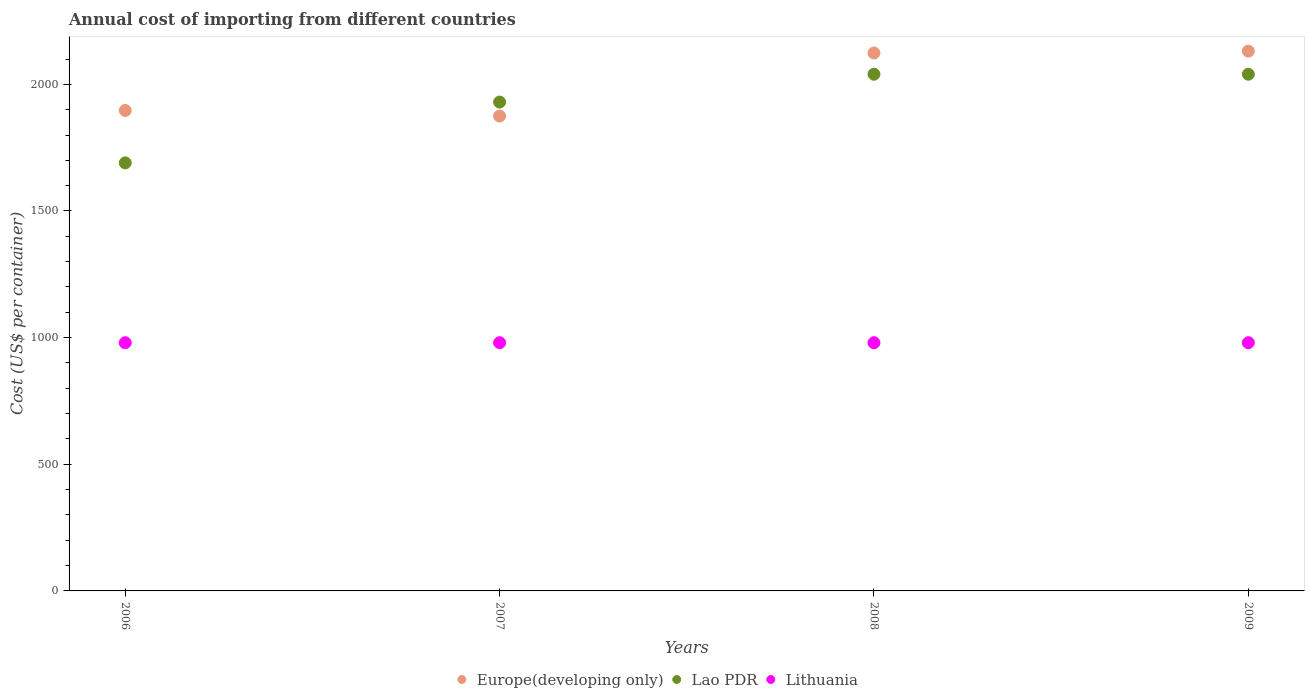How many different coloured dotlines are there?
Keep it short and to the point. 3. What is the total annual cost of importing in Lao PDR in 2006?
Your response must be concise. 1690. Across all years, what is the maximum total annual cost of importing in Lao PDR?
Your response must be concise. 2040. Across all years, what is the minimum total annual cost of importing in Europe(developing only)?
Offer a very short reply. 1874.94. In which year was the total annual cost of importing in Lao PDR maximum?
Ensure brevity in your answer.  2008. In which year was the total annual cost of importing in Lao PDR minimum?
Your answer should be compact. 2006. What is the total total annual cost of importing in Europe(developing only) in the graph?
Keep it short and to the point. 8026.94. What is the difference between the total annual cost of importing in Europe(developing only) in 2007 and that in 2008?
Ensure brevity in your answer.  -249. What is the difference between the total annual cost of importing in Europe(developing only) in 2007 and the total annual cost of importing in Lao PDR in 2009?
Make the answer very short. -165.06. What is the average total annual cost of importing in Lithuania per year?
Make the answer very short. 980. In the year 2008, what is the difference between the total annual cost of importing in Lao PDR and total annual cost of importing in Lithuania?
Ensure brevity in your answer.  1060. In how many years, is the total annual cost of importing in Lithuania greater than 600 US$?
Provide a short and direct response. 4. What is the ratio of the total annual cost of importing in Lao PDR in 2006 to that in 2009?
Provide a succinct answer. 0.83. Is the total annual cost of importing in Europe(developing only) in 2007 less than that in 2009?
Keep it short and to the point. Yes. What is the difference between the highest and the second highest total annual cost of importing in Europe(developing only)?
Provide a short and direct response. 7.16. What is the difference between the highest and the lowest total annual cost of importing in Lao PDR?
Offer a terse response. 350. In how many years, is the total annual cost of importing in Lithuania greater than the average total annual cost of importing in Lithuania taken over all years?
Make the answer very short. 0. Is the sum of the total annual cost of importing in Lao PDR in 2008 and 2009 greater than the maximum total annual cost of importing in Lithuania across all years?
Provide a short and direct response. Yes. Is it the case that in every year, the sum of the total annual cost of importing in Lithuania and total annual cost of importing in Lao PDR  is greater than the total annual cost of importing in Europe(developing only)?
Keep it short and to the point. Yes. Does the total annual cost of importing in Lao PDR monotonically increase over the years?
Make the answer very short. No. Is the total annual cost of importing in Lithuania strictly greater than the total annual cost of importing in Europe(developing only) over the years?
Your response must be concise. No. Is the total annual cost of importing in Lithuania strictly less than the total annual cost of importing in Lao PDR over the years?
Make the answer very short. Yes. How many years are there in the graph?
Offer a terse response. 4. Are the values on the major ticks of Y-axis written in scientific E-notation?
Offer a very short reply. No. Does the graph contain grids?
Your response must be concise. No. Where does the legend appear in the graph?
Provide a short and direct response. Bottom center. How are the legend labels stacked?
Keep it short and to the point. Horizontal. What is the title of the graph?
Provide a short and direct response. Annual cost of importing from different countries. What is the label or title of the Y-axis?
Ensure brevity in your answer.  Cost (US$ per container). What is the Cost (US$ per container) in Europe(developing only) in 2006?
Keep it short and to the point. 1896.94. What is the Cost (US$ per container) of Lao PDR in 2006?
Your answer should be compact. 1690. What is the Cost (US$ per container) in Lithuania in 2006?
Give a very brief answer. 980. What is the Cost (US$ per container) in Europe(developing only) in 2007?
Your answer should be very brief. 1874.94. What is the Cost (US$ per container) of Lao PDR in 2007?
Offer a terse response. 1930. What is the Cost (US$ per container) in Lithuania in 2007?
Make the answer very short. 980. What is the Cost (US$ per container) of Europe(developing only) in 2008?
Your answer should be very brief. 2123.94. What is the Cost (US$ per container) in Lao PDR in 2008?
Ensure brevity in your answer.  2040. What is the Cost (US$ per container) of Lithuania in 2008?
Your answer should be very brief. 980. What is the Cost (US$ per container) in Europe(developing only) in 2009?
Offer a terse response. 2131.11. What is the Cost (US$ per container) of Lao PDR in 2009?
Ensure brevity in your answer.  2040. What is the Cost (US$ per container) of Lithuania in 2009?
Your response must be concise. 980. Across all years, what is the maximum Cost (US$ per container) in Europe(developing only)?
Make the answer very short. 2131.11. Across all years, what is the maximum Cost (US$ per container) in Lao PDR?
Give a very brief answer. 2040. Across all years, what is the maximum Cost (US$ per container) of Lithuania?
Your answer should be compact. 980. Across all years, what is the minimum Cost (US$ per container) of Europe(developing only)?
Your answer should be compact. 1874.94. Across all years, what is the minimum Cost (US$ per container) in Lao PDR?
Provide a succinct answer. 1690. Across all years, what is the minimum Cost (US$ per container) of Lithuania?
Your answer should be compact. 980. What is the total Cost (US$ per container) of Europe(developing only) in the graph?
Offer a terse response. 8026.94. What is the total Cost (US$ per container) in Lao PDR in the graph?
Offer a terse response. 7700. What is the total Cost (US$ per container) of Lithuania in the graph?
Keep it short and to the point. 3920. What is the difference between the Cost (US$ per container) in Lao PDR in 2006 and that in 2007?
Keep it short and to the point. -240. What is the difference between the Cost (US$ per container) in Lithuania in 2006 and that in 2007?
Offer a terse response. 0. What is the difference between the Cost (US$ per container) of Europe(developing only) in 2006 and that in 2008?
Provide a succinct answer. -227. What is the difference between the Cost (US$ per container) of Lao PDR in 2006 and that in 2008?
Ensure brevity in your answer.  -350. What is the difference between the Cost (US$ per container) in Europe(developing only) in 2006 and that in 2009?
Offer a very short reply. -234.16. What is the difference between the Cost (US$ per container) of Lao PDR in 2006 and that in 2009?
Offer a very short reply. -350. What is the difference between the Cost (US$ per container) of Lithuania in 2006 and that in 2009?
Your answer should be very brief. 0. What is the difference between the Cost (US$ per container) of Europe(developing only) in 2007 and that in 2008?
Ensure brevity in your answer.  -249. What is the difference between the Cost (US$ per container) of Lao PDR in 2007 and that in 2008?
Your answer should be very brief. -110. What is the difference between the Cost (US$ per container) in Lithuania in 2007 and that in 2008?
Give a very brief answer. 0. What is the difference between the Cost (US$ per container) in Europe(developing only) in 2007 and that in 2009?
Keep it short and to the point. -256.16. What is the difference between the Cost (US$ per container) of Lao PDR in 2007 and that in 2009?
Your answer should be compact. -110. What is the difference between the Cost (US$ per container) of Europe(developing only) in 2008 and that in 2009?
Offer a terse response. -7.16. What is the difference between the Cost (US$ per container) in Lao PDR in 2008 and that in 2009?
Your answer should be very brief. 0. What is the difference between the Cost (US$ per container) of Lithuania in 2008 and that in 2009?
Offer a very short reply. 0. What is the difference between the Cost (US$ per container) in Europe(developing only) in 2006 and the Cost (US$ per container) in Lao PDR in 2007?
Provide a succinct answer. -33.06. What is the difference between the Cost (US$ per container) in Europe(developing only) in 2006 and the Cost (US$ per container) in Lithuania in 2007?
Provide a succinct answer. 916.94. What is the difference between the Cost (US$ per container) in Lao PDR in 2006 and the Cost (US$ per container) in Lithuania in 2007?
Offer a terse response. 710. What is the difference between the Cost (US$ per container) of Europe(developing only) in 2006 and the Cost (US$ per container) of Lao PDR in 2008?
Your answer should be compact. -143.06. What is the difference between the Cost (US$ per container) of Europe(developing only) in 2006 and the Cost (US$ per container) of Lithuania in 2008?
Ensure brevity in your answer.  916.94. What is the difference between the Cost (US$ per container) of Lao PDR in 2006 and the Cost (US$ per container) of Lithuania in 2008?
Provide a succinct answer. 710. What is the difference between the Cost (US$ per container) in Europe(developing only) in 2006 and the Cost (US$ per container) in Lao PDR in 2009?
Provide a short and direct response. -143.06. What is the difference between the Cost (US$ per container) in Europe(developing only) in 2006 and the Cost (US$ per container) in Lithuania in 2009?
Offer a terse response. 916.94. What is the difference between the Cost (US$ per container) of Lao PDR in 2006 and the Cost (US$ per container) of Lithuania in 2009?
Your answer should be very brief. 710. What is the difference between the Cost (US$ per container) in Europe(developing only) in 2007 and the Cost (US$ per container) in Lao PDR in 2008?
Keep it short and to the point. -165.06. What is the difference between the Cost (US$ per container) of Europe(developing only) in 2007 and the Cost (US$ per container) of Lithuania in 2008?
Keep it short and to the point. 894.94. What is the difference between the Cost (US$ per container) in Lao PDR in 2007 and the Cost (US$ per container) in Lithuania in 2008?
Provide a succinct answer. 950. What is the difference between the Cost (US$ per container) in Europe(developing only) in 2007 and the Cost (US$ per container) in Lao PDR in 2009?
Offer a terse response. -165.06. What is the difference between the Cost (US$ per container) in Europe(developing only) in 2007 and the Cost (US$ per container) in Lithuania in 2009?
Ensure brevity in your answer.  894.94. What is the difference between the Cost (US$ per container) of Lao PDR in 2007 and the Cost (US$ per container) of Lithuania in 2009?
Provide a short and direct response. 950. What is the difference between the Cost (US$ per container) in Europe(developing only) in 2008 and the Cost (US$ per container) in Lao PDR in 2009?
Provide a succinct answer. 83.94. What is the difference between the Cost (US$ per container) in Europe(developing only) in 2008 and the Cost (US$ per container) in Lithuania in 2009?
Your answer should be very brief. 1143.94. What is the difference between the Cost (US$ per container) in Lao PDR in 2008 and the Cost (US$ per container) in Lithuania in 2009?
Offer a terse response. 1060. What is the average Cost (US$ per container) of Europe(developing only) per year?
Offer a very short reply. 2006.73. What is the average Cost (US$ per container) in Lao PDR per year?
Offer a terse response. 1925. What is the average Cost (US$ per container) of Lithuania per year?
Offer a terse response. 980. In the year 2006, what is the difference between the Cost (US$ per container) of Europe(developing only) and Cost (US$ per container) of Lao PDR?
Provide a short and direct response. 206.94. In the year 2006, what is the difference between the Cost (US$ per container) of Europe(developing only) and Cost (US$ per container) of Lithuania?
Keep it short and to the point. 916.94. In the year 2006, what is the difference between the Cost (US$ per container) of Lao PDR and Cost (US$ per container) of Lithuania?
Ensure brevity in your answer.  710. In the year 2007, what is the difference between the Cost (US$ per container) of Europe(developing only) and Cost (US$ per container) of Lao PDR?
Give a very brief answer. -55.06. In the year 2007, what is the difference between the Cost (US$ per container) in Europe(developing only) and Cost (US$ per container) in Lithuania?
Provide a succinct answer. 894.94. In the year 2007, what is the difference between the Cost (US$ per container) in Lao PDR and Cost (US$ per container) in Lithuania?
Make the answer very short. 950. In the year 2008, what is the difference between the Cost (US$ per container) in Europe(developing only) and Cost (US$ per container) in Lao PDR?
Provide a succinct answer. 83.94. In the year 2008, what is the difference between the Cost (US$ per container) in Europe(developing only) and Cost (US$ per container) in Lithuania?
Make the answer very short. 1143.94. In the year 2008, what is the difference between the Cost (US$ per container) of Lao PDR and Cost (US$ per container) of Lithuania?
Offer a terse response. 1060. In the year 2009, what is the difference between the Cost (US$ per container) of Europe(developing only) and Cost (US$ per container) of Lao PDR?
Offer a terse response. 91.11. In the year 2009, what is the difference between the Cost (US$ per container) in Europe(developing only) and Cost (US$ per container) in Lithuania?
Provide a short and direct response. 1151.11. In the year 2009, what is the difference between the Cost (US$ per container) in Lao PDR and Cost (US$ per container) in Lithuania?
Your response must be concise. 1060. What is the ratio of the Cost (US$ per container) in Europe(developing only) in 2006 to that in 2007?
Give a very brief answer. 1.01. What is the ratio of the Cost (US$ per container) in Lao PDR in 2006 to that in 2007?
Offer a terse response. 0.88. What is the ratio of the Cost (US$ per container) of Lithuania in 2006 to that in 2007?
Your answer should be compact. 1. What is the ratio of the Cost (US$ per container) of Europe(developing only) in 2006 to that in 2008?
Give a very brief answer. 0.89. What is the ratio of the Cost (US$ per container) in Lao PDR in 2006 to that in 2008?
Provide a succinct answer. 0.83. What is the ratio of the Cost (US$ per container) in Lithuania in 2006 to that in 2008?
Offer a terse response. 1. What is the ratio of the Cost (US$ per container) of Europe(developing only) in 2006 to that in 2009?
Provide a short and direct response. 0.89. What is the ratio of the Cost (US$ per container) of Lao PDR in 2006 to that in 2009?
Provide a short and direct response. 0.83. What is the ratio of the Cost (US$ per container) in Europe(developing only) in 2007 to that in 2008?
Ensure brevity in your answer.  0.88. What is the ratio of the Cost (US$ per container) of Lao PDR in 2007 to that in 2008?
Offer a very short reply. 0.95. What is the ratio of the Cost (US$ per container) in Lithuania in 2007 to that in 2008?
Keep it short and to the point. 1. What is the ratio of the Cost (US$ per container) in Europe(developing only) in 2007 to that in 2009?
Ensure brevity in your answer.  0.88. What is the ratio of the Cost (US$ per container) of Lao PDR in 2007 to that in 2009?
Give a very brief answer. 0.95. What is the ratio of the Cost (US$ per container) of Lao PDR in 2008 to that in 2009?
Your response must be concise. 1. What is the ratio of the Cost (US$ per container) in Lithuania in 2008 to that in 2009?
Give a very brief answer. 1. What is the difference between the highest and the second highest Cost (US$ per container) in Europe(developing only)?
Give a very brief answer. 7.16. What is the difference between the highest and the second highest Cost (US$ per container) of Lao PDR?
Make the answer very short. 0. What is the difference between the highest and the second highest Cost (US$ per container) of Lithuania?
Provide a succinct answer. 0. What is the difference between the highest and the lowest Cost (US$ per container) in Europe(developing only)?
Keep it short and to the point. 256.16. What is the difference between the highest and the lowest Cost (US$ per container) of Lao PDR?
Make the answer very short. 350. What is the difference between the highest and the lowest Cost (US$ per container) in Lithuania?
Make the answer very short. 0. 